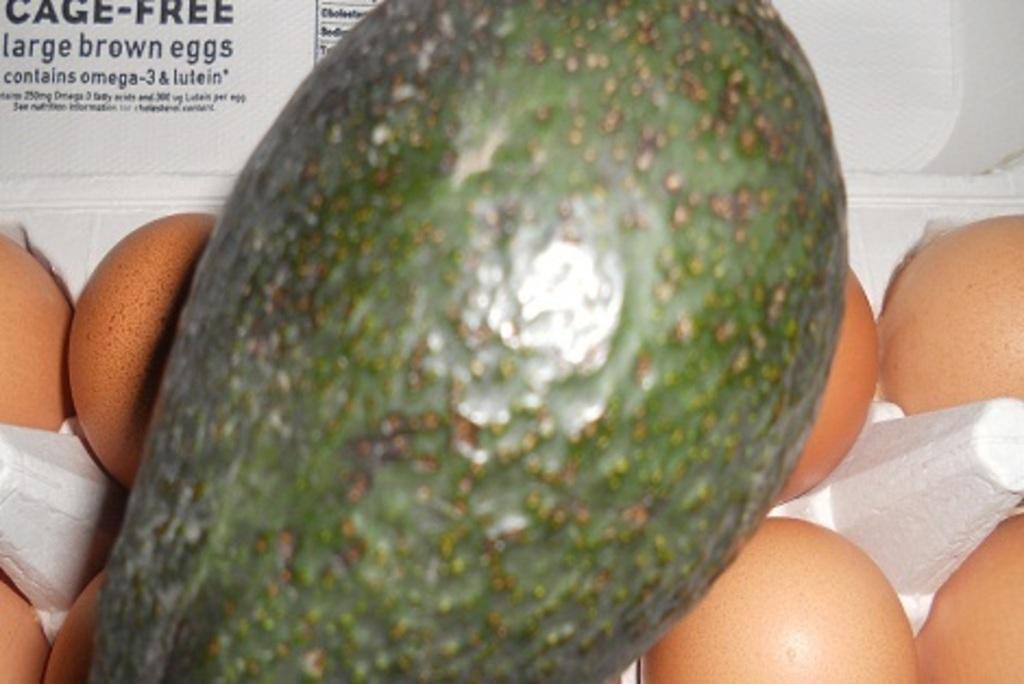How would you summarize this image in a sentence or two? In this picture we can observe a green color fruit. There are some eggs which are in orange color. On the left side we can observe black color words on the white background. 